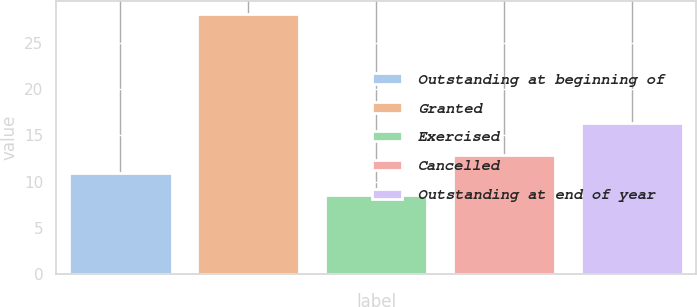<chart> <loc_0><loc_0><loc_500><loc_500><bar_chart><fcel>Outstanding at beginning of<fcel>Granted<fcel>Exercised<fcel>Cancelled<fcel>Outstanding at end of year<nl><fcel>10.97<fcel>28.1<fcel>8.62<fcel>12.92<fcel>16.38<nl></chart> 